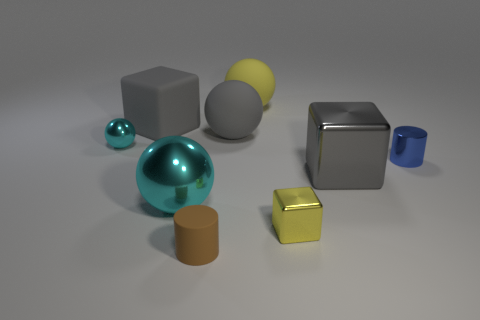Subtract all blocks. How many objects are left? 6 Subtract all big metallic spheres. Subtract all big yellow shiny cylinders. How many objects are left? 8 Add 5 tiny metallic cylinders. How many tiny metallic cylinders are left? 6 Add 9 gray balls. How many gray balls exist? 10 Subtract 0 blue cubes. How many objects are left? 9 